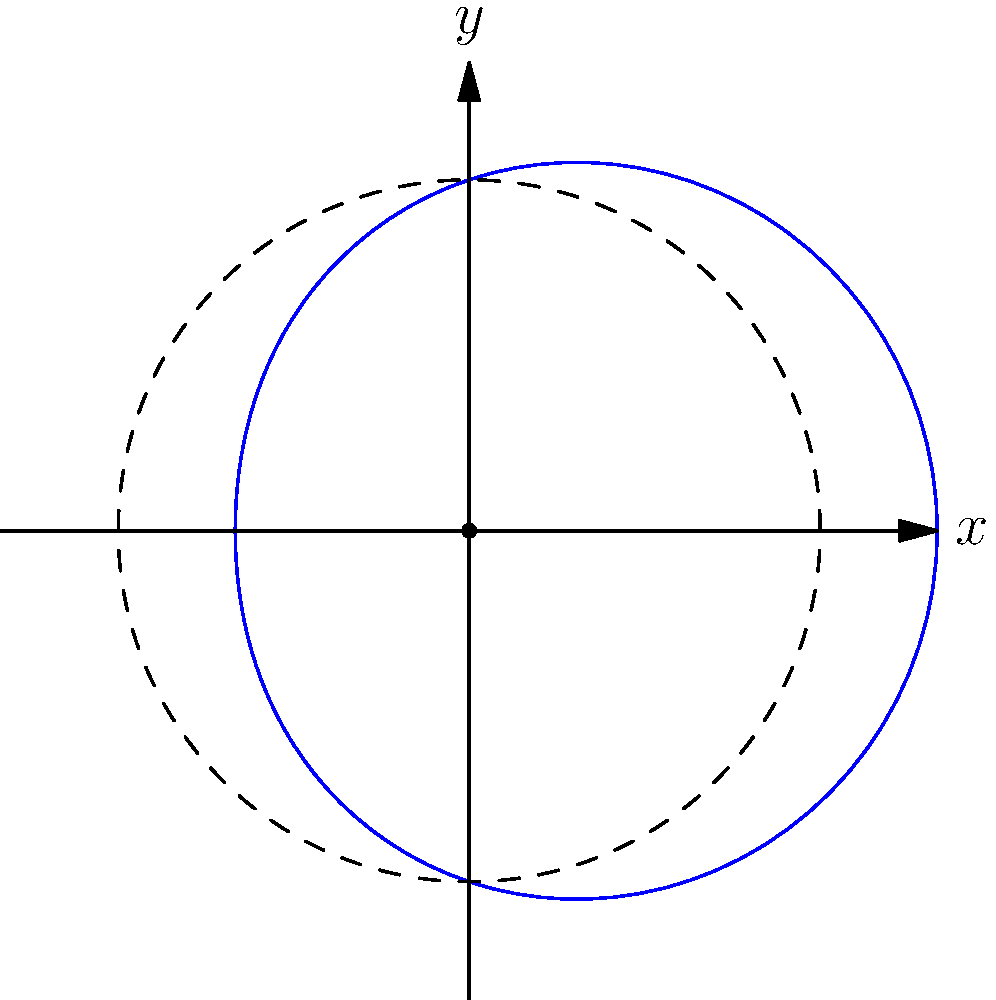In optimizing a tiny home's living space, you model the floor plan using polar coordinates. The boundary of the living area is given by the equation $r = 3 + \cos(\theta)$, where $r$ is in meters. Calculate the total floor area of this uniquely shaped living space. To find the area enclosed by the polar curve $r = 3 + \cos(\theta)$, we'll follow these steps:

1) The formula for the area enclosed by a polar curve is:

   $$A = \frac{1}{2} \int_{0}^{2\pi} r^2(\theta) d\theta$$

2) Substitute our function $r(\theta) = 3 + \cos(\theta)$ into this formula:

   $$A = \frac{1}{2} \int_{0}^{2\pi} (3 + \cos(\theta))^2 d\theta$$

3) Expand the squared term:

   $$A = \frac{1}{2} \int_{0}^{2\pi} (9 + 6\cos(\theta) + \cos^2(\theta)) d\theta$$

4) Integrate each term:
   
   $$A = \frac{1}{2} [9\theta + 6\sin(\theta) + \frac{1}{2}\theta + \frac{1}{4}\sin(2\theta)]_{0}^{2\pi}$$

5) Evaluate the integral:

   $$A = \frac{1}{2} [(9 \cdot 2\pi + 0 + \frac{1}{2} \cdot 2\pi + 0) - (0 + 0 + 0 + 0)]$$

   $$A = \frac{1}{2} [18\pi + \pi] = \frac{19\pi}{2}$$

6) Therefore, the total floor area is $\frac{19\pi}{2}$ square meters.
Answer: $\frac{19\pi}{2}$ m² 